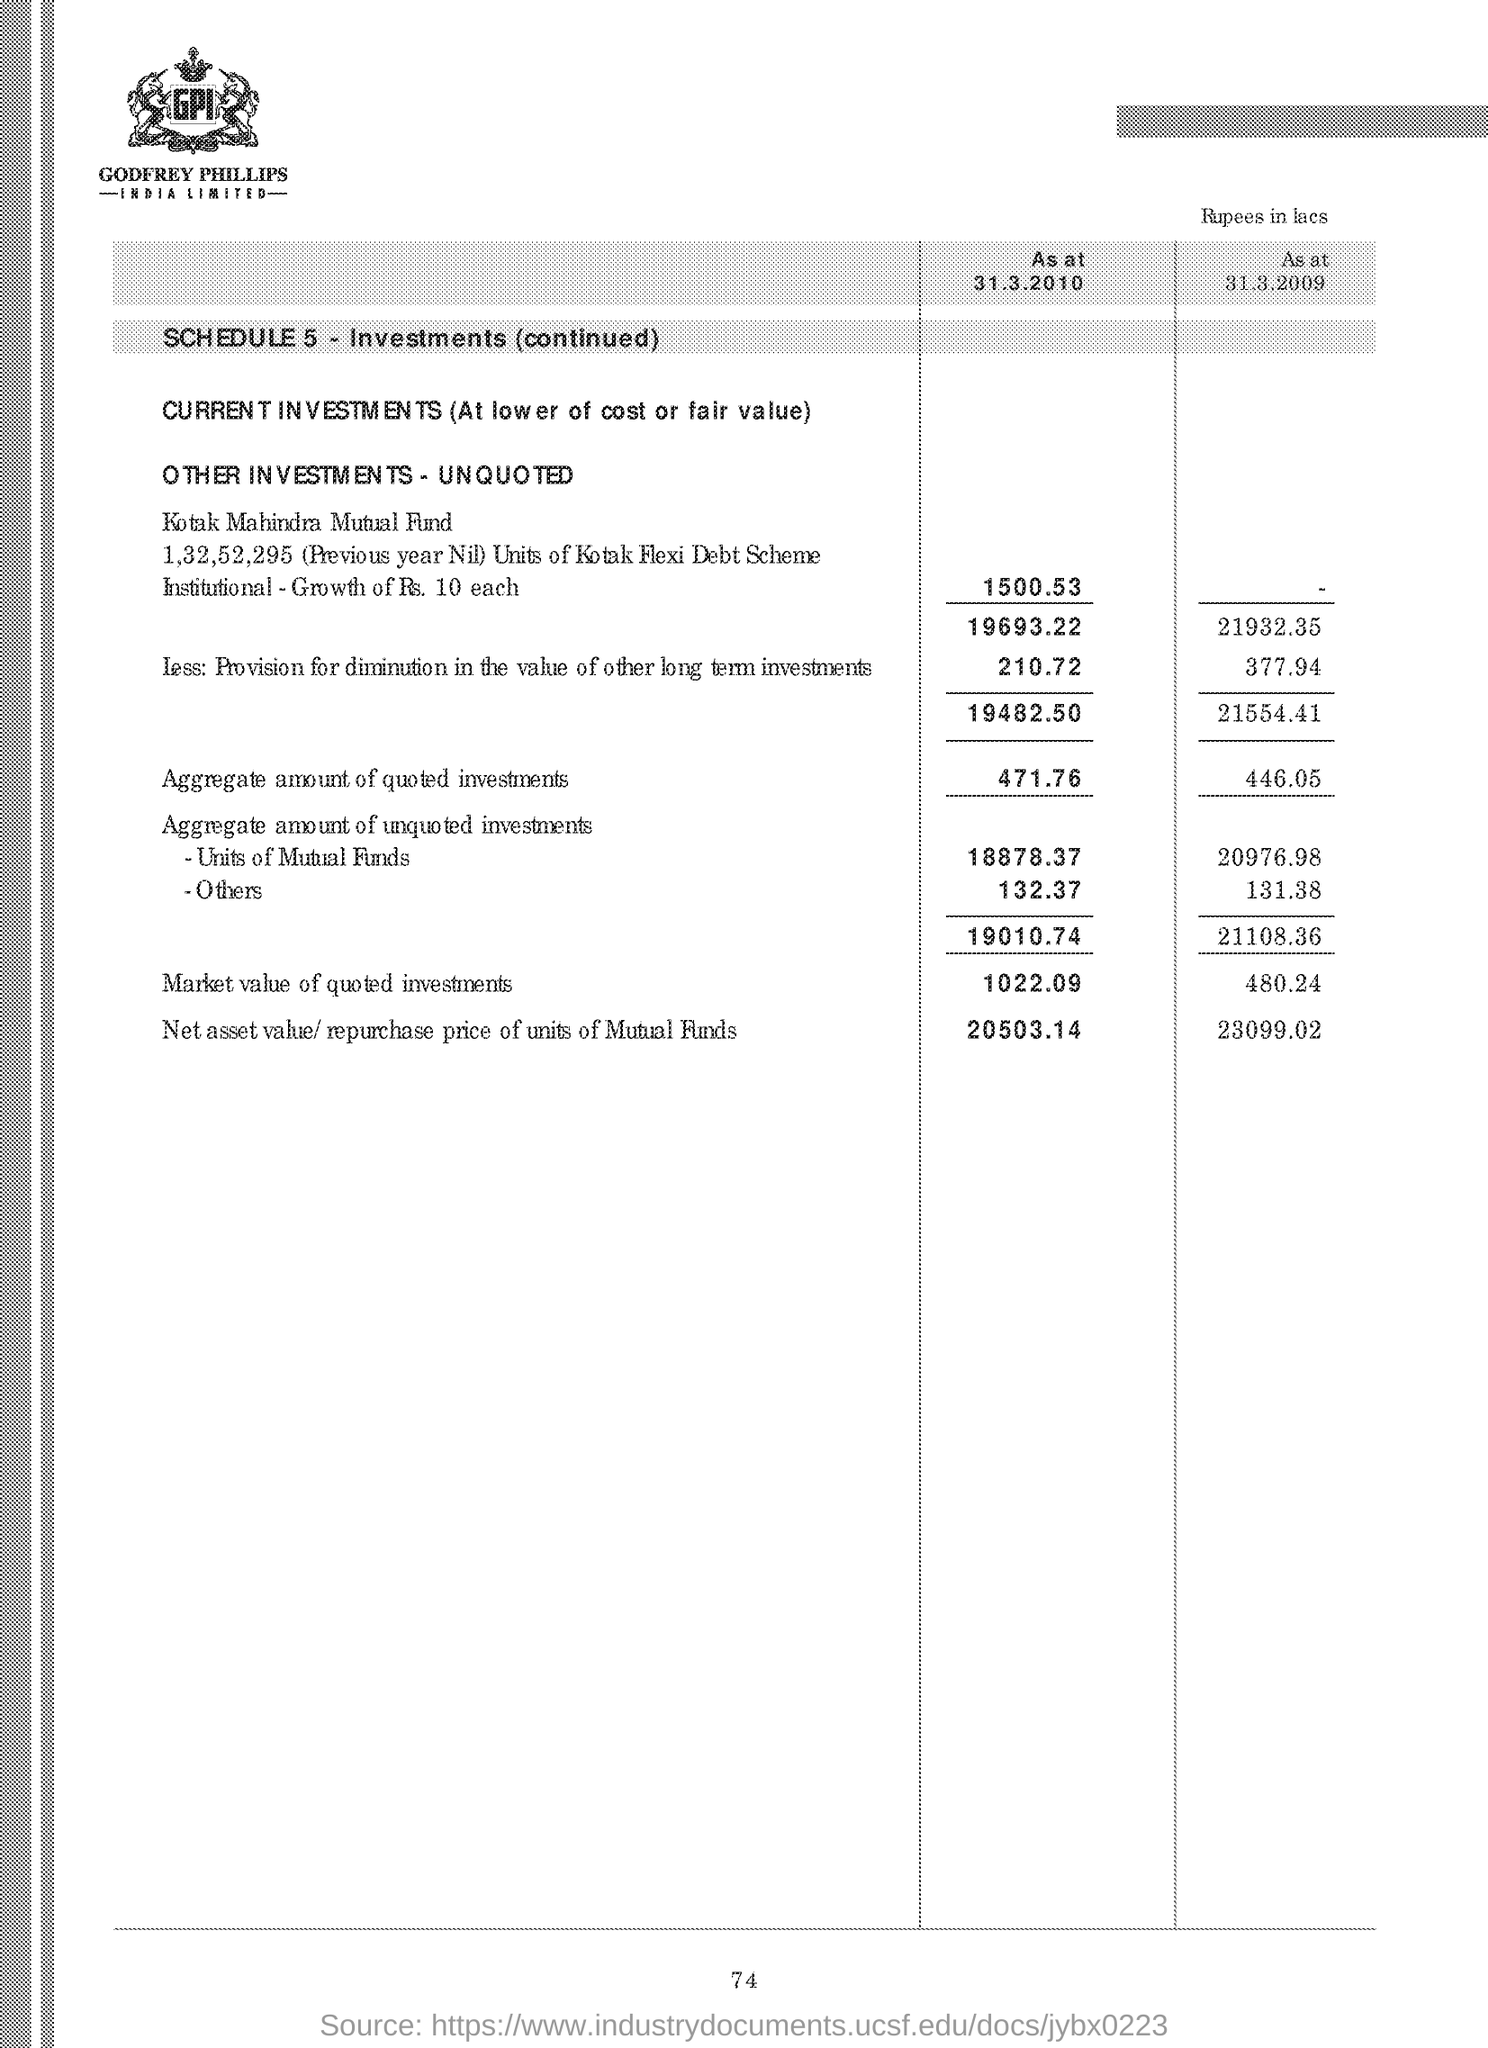List a handful of essential elements in this visual. The company logo at the top features the letters 'GPI', which are written in a clear and legible font. What is the number of Investments? It is five. The aggregate amount of quoted investments on March 31st, 2010 was 471.76. As of March 31, 2010, the net asset value (NAV) or repurchase price of units in mutual funds was 20,503.14. 